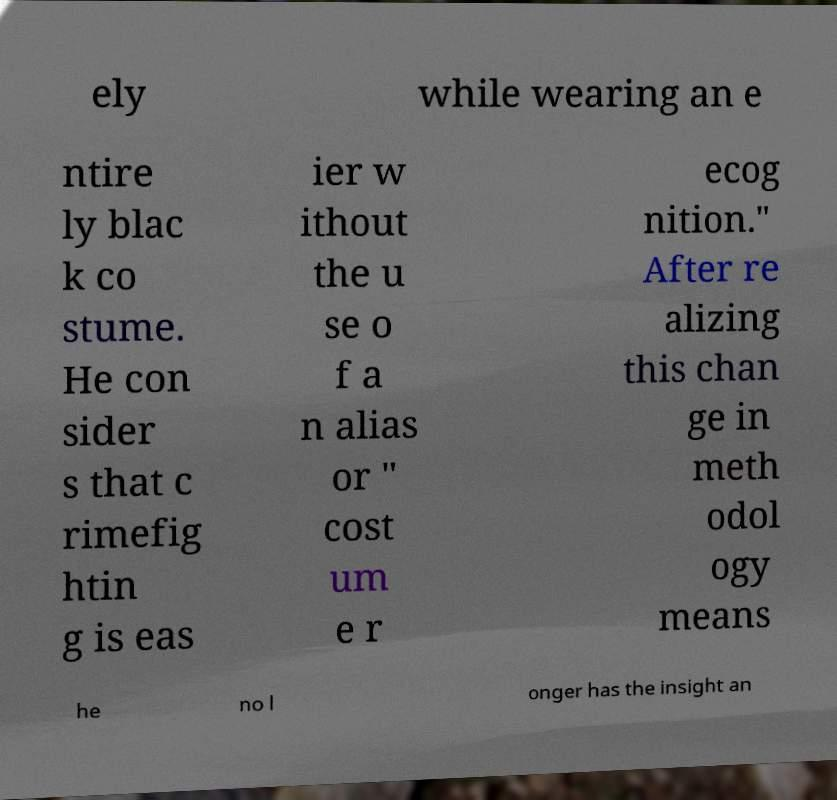Can you read and provide the text displayed in the image?This photo seems to have some interesting text. Can you extract and type it out for me? ely while wearing an e ntire ly blac k co stume. He con sider s that c rimefig htin g is eas ier w ithout the u se o f a n alias or " cost um e r ecog nition." After re alizing this chan ge in meth odol ogy means he no l onger has the insight an 